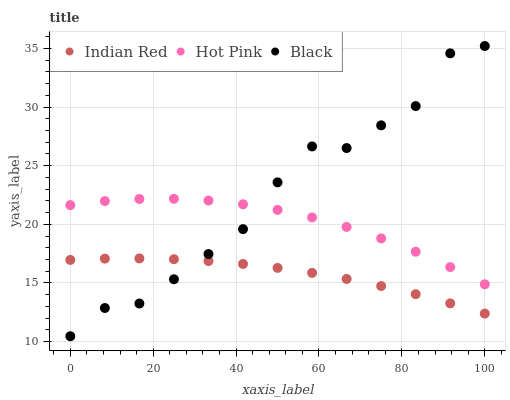Does Indian Red have the minimum area under the curve?
Answer yes or no. Yes. Does Black have the maximum area under the curve?
Answer yes or no. Yes. Does Black have the minimum area under the curve?
Answer yes or no. No. Does Indian Red have the maximum area under the curve?
Answer yes or no. No. Is Indian Red the smoothest?
Answer yes or no. Yes. Is Black the roughest?
Answer yes or no. Yes. Is Black the smoothest?
Answer yes or no. No. Is Indian Red the roughest?
Answer yes or no. No. Does Black have the lowest value?
Answer yes or no. Yes. Does Indian Red have the lowest value?
Answer yes or no. No. Does Black have the highest value?
Answer yes or no. Yes. Does Indian Red have the highest value?
Answer yes or no. No. Is Indian Red less than Hot Pink?
Answer yes or no. Yes. Is Hot Pink greater than Indian Red?
Answer yes or no. Yes. Does Indian Red intersect Black?
Answer yes or no. Yes. Is Indian Red less than Black?
Answer yes or no. No. Is Indian Red greater than Black?
Answer yes or no. No. Does Indian Red intersect Hot Pink?
Answer yes or no. No. 